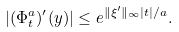Convert formula to latex. <formula><loc_0><loc_0><loc_500><loc_500>| ( \Phi _ { t } ^ { a } ) ^ { \prime } ( y ) | \leq e ^ { \| \xi ^ { \prime } \| _ { \infty } | t | / a } .</formula> 